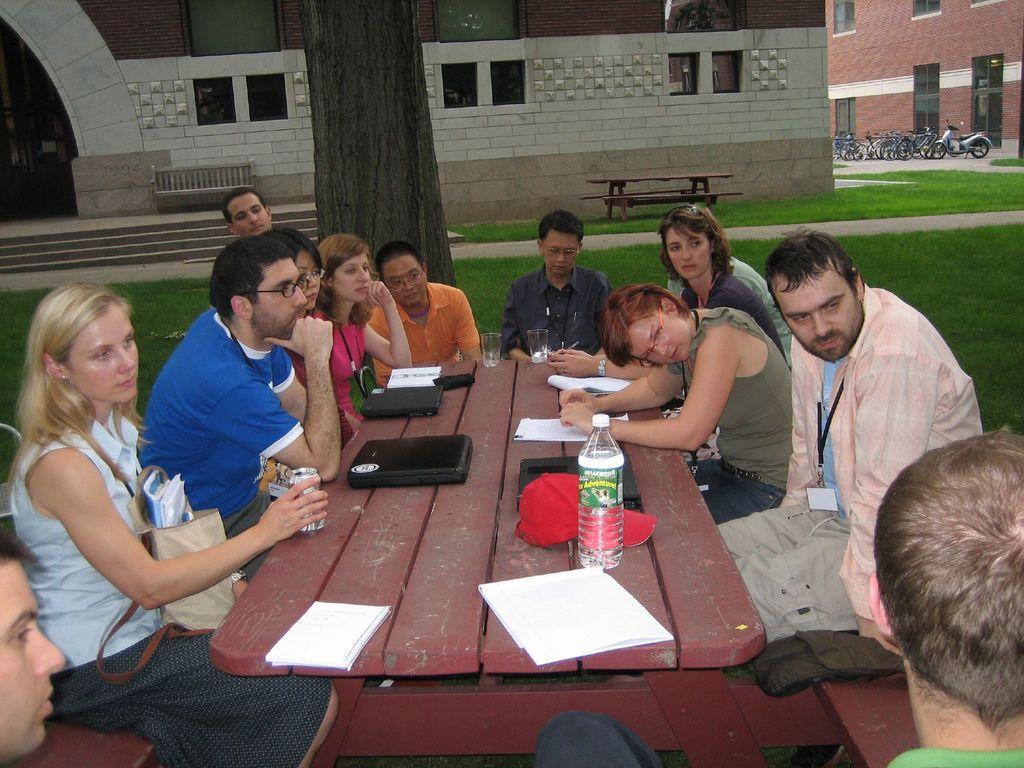Could you give a brief overview of what you see in this image? In this picture there are group of people who are sitting on the chair. There is a bottle, red cap , papers, laptop, black wallet, glass on the table. There is a bench, some grass on the ground. To the right There are few vehicles on the path. There is a building and a tree. 